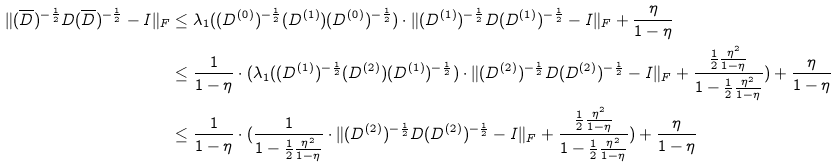<formula> <loc_0><loc_0><loc_500><loc_500>\| ( \overline { D } ) ^ { - \frac { 1 } { 2 } } D ( \overline { D } ) ^ { - \frac { 1 } { 2 } } - I \| _ { F } & \leq \lambda _ { 1 } ( ( D ^ { ( 0 ) } ) ^ { - \frac { 1 } { 2 } } ( D ^ { ( 1 ) } ) ( D ^ { ( 0 ) } ) ^ { - \frac { 1 } { 2 } } ) \cdot \| ( D ^ { ( 1 ) } ) ^ { - \frac { 1 } { 2 } } D ( D ^ { ( 1 ) } ) ^ { - \frac { 1 } { 2 } } - I \| _ { F } + \frac { \eta } { 1 - \eta } \\ & \leq \frac { 1 } { 1 - \eta } \cdot ( \lambda _ { 1 } ( ( D ^ { ( 1 ) } ) ^ { - \frac { 1 } { 2 } } ( D ^ { ( 2 ) } ) ( D ^ { ( 1 ) } ) ^ { - \frac { 1 } { 2 } } ) \cdot \| ( D ^ { ( 2 ) } ) ^ { - \frac { 1 } { 2 } } D ( D ^ { ( 2 ) } ) ^ { - \frac { 1 } { 2 } } - I \| _ { F } + \frac { \frac { 1 } { 2 } \frac { \eta ^ { 2 } } { 1 - \eta } } { 1 - \frac { 1 } { 2 } \frac { \eta ^ { 2 } } { 1 - \eta } } ) + \frac { \eta } { 1 - \eta } \\ & \leq \frac { 1 } { 1 - \eta } \cdot ( \frac { 1 } { 1 - \frac { 1 } { 2 } \frac { \eta ^ { 2 } } { 1 - \eta } } \cdot \| ( D ^ { ( 2 ) } ) ^ { - \frac { 1 } { 2 } } D ( D ^ { ( 2 ) } ) ^ { - \frac { 1 } { 2 } } - I \| _ { F } + \frac { \frac { 1 } { 2 } \frac { \eta ^ { 2 } } { 1 - \eta } } { 1 - \frac { 1 } { 2 } \frac { \eta ^ { 2 } } { 1 - \eta } } ) + \frac { \eta } { 1 - \eta }</formula> 